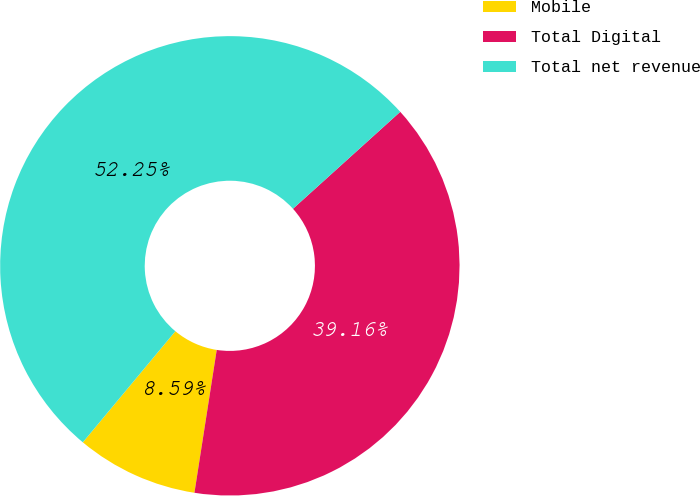<chart> <loc_0><loc_0><loc_500><loc_500><pie_chart><fcel>Mobile<fcel>Total Digital<fcel>Total net revenue<nl><fcel>8.59%<fcel>39.16%<fcel>52.25%<nl></chart> 